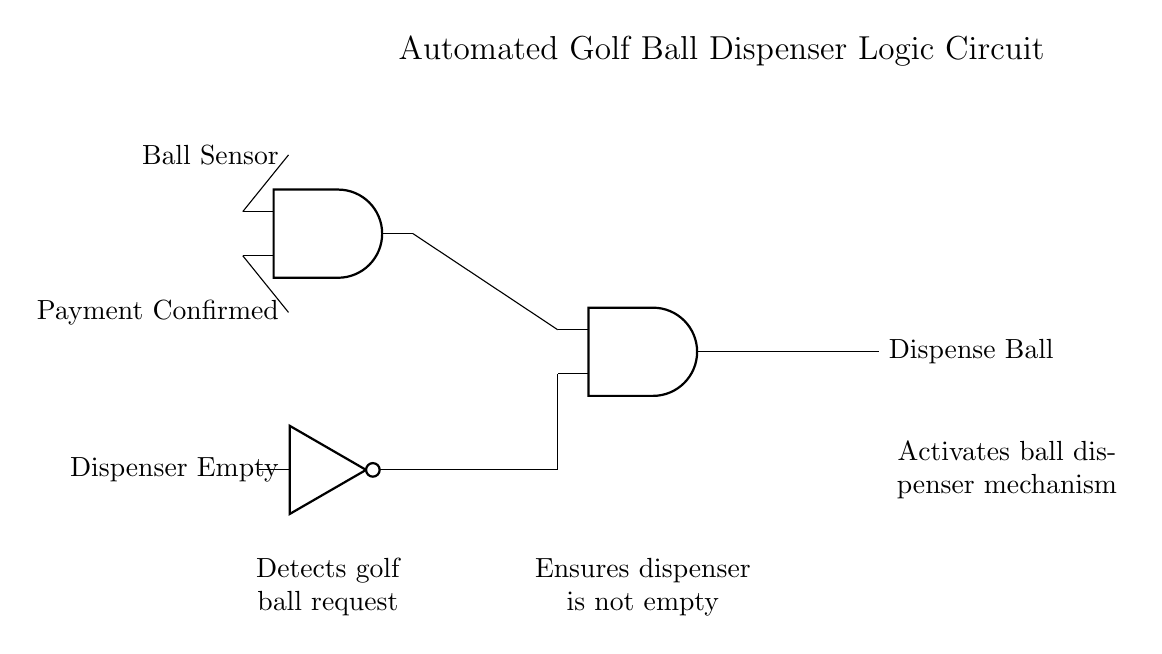What are the inputs to the circuit? The circuit has three inputs: the Ball Sensor, Payment Confirmed, and Dispenser Empty. These inputs control the logic gates and influence the output for dispensing the ball.
Answer: Ball Sensor, Payment Confirmed, Dispenser Empty What type of logic gates are used in this circuit? The circuit contains an AND gate and a NOT gate. The AND gates require multiple conditions to be true for the output, while the NOT gate inverts the state of the Dispenser Empty signal.
Answer: AND gate, NOT gate What is the purpose of the first AND gate? The first AND gate takes the Ball Sensor and Payment Confirmed inputs to determine if a ball request can be fulfilled. If both conditions are met, the output will enable the next stage of the circuit.
Answer: To process ball request conditions What condition prevents ball dispensing from occurring? The Dispenser Empty condition, being input into the NOT gate, prevents the dispensing of the ball. If the dispenser is empty, the NOT gate will output a signal that negatively impacts the second AND gate.
Answer: Dispenser Empty How many AND gates are there in this circuit? There are two AND gates present in the circuit. One processes the initial conditions, and the second processes the output from the first AND gate along with the inverted Dispenser Empty input.
Answer: Two What does the output of the second AND gate do? The output of the second AND gate activates the mechanism to dispense the golf ball, initiating the action required when all conditions for ball dispensing are met.
Answer: Activates ball dispenser mechanism What is the role of the NOT gate in the circuit? The NOT gate's role is to check if the dispenser is empty and invert that signal. If the dispenser is empty, it prevents the second AND gate from producing an output, thereby stopping ball dispensing.
Answer: Inverts the Dispenser Empty signal 